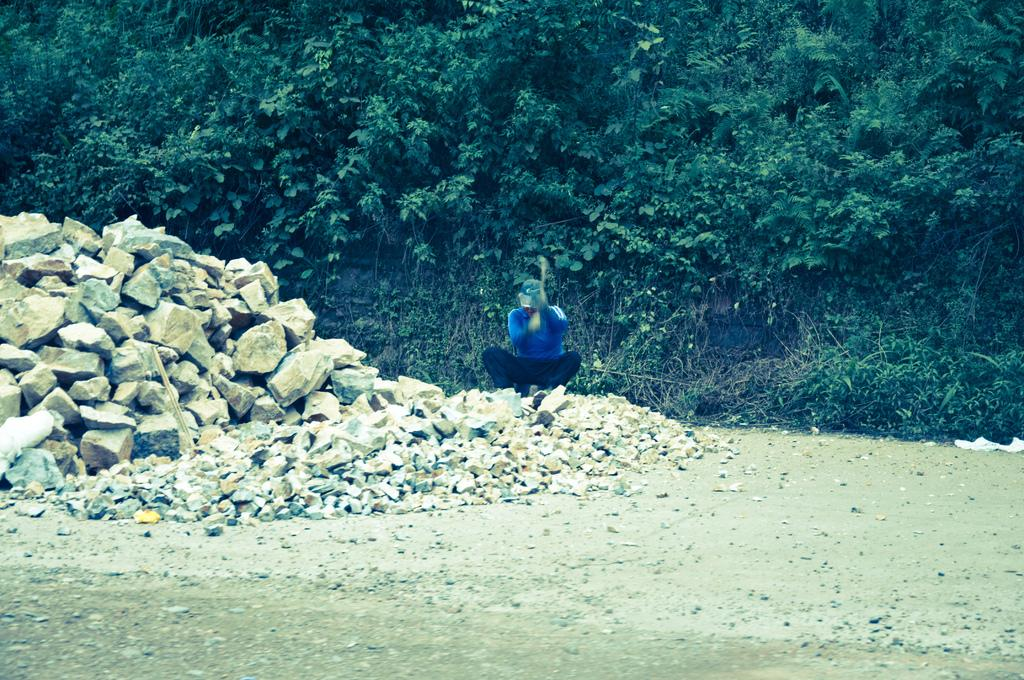Who or what is the main subject in the image? There is a person in the image. What is the person wearing? The person is wearing a blue and black color dress. What is in front of the person? There are many rocks in front of the person. What can be seen in the background of the image? There are many trees in the background of the image. What type of cracker is the person holding in the image? There is no cracker present in the image. What color is the suit the person is wearing in the image? The person is not wearing a suit in the image; they are wearing a blue and black color dress. 